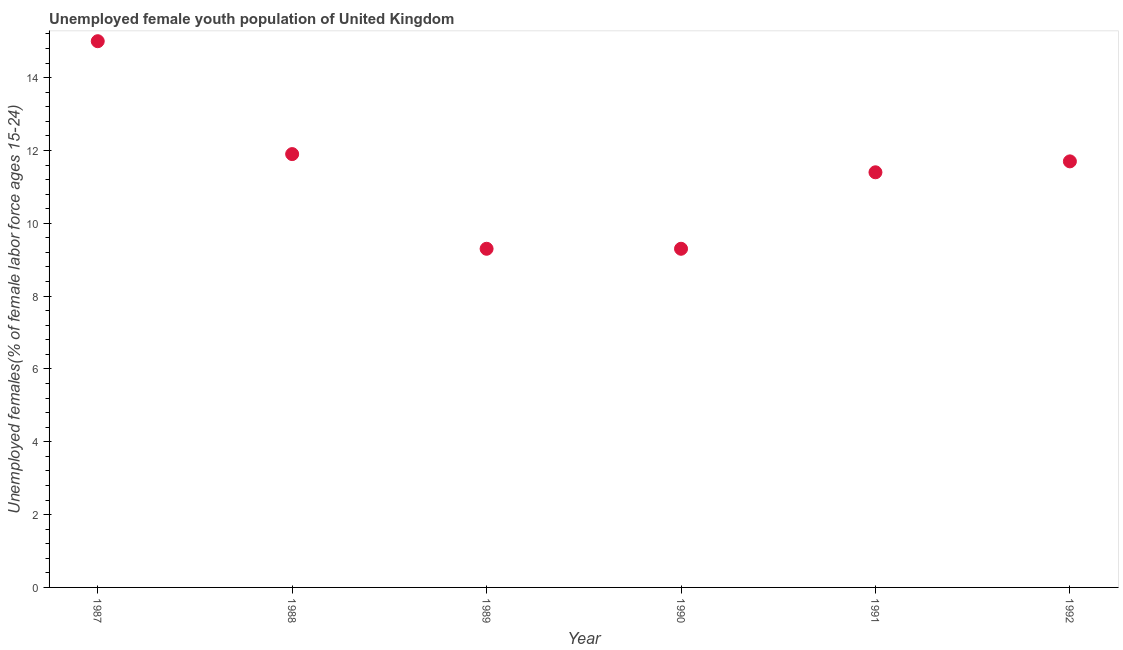What is the unemployed female youth in 1992?
Offer a very short reply. 11.7. Across all years, what is the maximum unemployed female youth?
Provide a short and direct response. 15. Across all years, what is the minimum unemployed female youth?
Provide a short and direct response. 9.3. What is the sum of the unemployed female youth?
Provide a short and direct response. 68.6. What is the difference between the unemployed female youth in 1987 and 1991?
Provide a short and direct response. 3.6. What is the average unemployed female youth per year?
Keep it short and to the point. 11.43. What is the median unemployed female youth?
Offer a very short reply. 11.55. In how many years, is the unemployed female youth greater than 6 %?
Provide a succinct answer. 6. Do a majority of the years between 1990 and 1988 (inclusive) have unemployed female youth greater than 10 %?
Keep it short and to the point. No. What is the ratio of the unemployed female youth in 1988 to that in 1989?
Your response must be concise. 1.28. Is the unemployed female youth in 1990 less than that in 1991?
Keep it short and to the point. Yes. Is the difference between the unemployed female youth in 1987 and 1991 greater than the difference between any two years?
Offer a terse response. No. What is the difference between the highest and the second highest unemployed female youth?
Your answer should be very brief. 3.1. Is the sum of the unemployed female youth in 1990 and 1991 greater than the maximum unemployed female youth across all years?
Ensure brevity in your answer.  Yes. What is the difference between the highest and the lowest unemployed female youth?
Ensure brevity in your answer.  5.7. In how many years, is the unemployed female youth greater than the average unemployed female youth taken over all years?
Your answer should be very brief. 3. Are the values on the major ticks of Y-axis written in scientific E-notation?
Your answer should be very brief. No. Does the graph contain any zero values?
Offer a very short reply. No. Does the graph contain grids?
Offer a very short reply. No. What is the title of the graph?
Offer a terse response. Unemployed female youth population of United Kingdom. What is the label or title of the X-axis?
Keep it short and to the point. Year. What is the label or title of the Y-axis?
Your answer should be compact. Unemployed females(% of female labor force ages 15-24). What is the Unemployed females(% of female labor force ages 15-24) in 1988?
Give a very brief answer. 11.9. What is the Unemployed females(% of female labor force ages 15-24) in 1989?
Provide a short and direct response. 9.3. What is the Unemployed females(% of female labor force ages 15-24) in 1990?
Make the answer very short. 9.3. What is the Unemployed females(% of female labor force ages 15-24) in 1991?
Keep it short and to the point. 11.4. What is the Unemployed females(% of female labor force ages 15-24) in 1992?
Your answer should be compact. 11.7. What is the difference between the Unemployed females(% of female labor force ages 15-24) in 1987 and 1988?
Provide a short and direct response. 3.1. What is the difference between the Unemployed females(% of female labor force ages 15-24) in 1987 and 1991?
Your response must be concise. 3.6. What is the difference between the Unemployed females(% of female labor force ages 15-24) in 1987 and 1992?
Your answer should be compact. 3.3. What is the difference between the Unemployed females(% of female labor force ages 15-24) in 1988 and 1989?
Offer a terse response. 2.6. What is the difference between the Unemployed females(% of female labor force ages 15-24) in 1988 and 1990?
Give a very brief answer. 2.6. What is the difference between the Unemployed females(% of female labor force ages 15-24) in 1988 and 1991?
Offer a very short reply. 0.5. What is the difference between the Unemployed females(% of female labor force ages 15-24) in 1988 and 1992?
Give a very brief answer. 0.2. What is the difference between the Unemployed females(% of female labor force ages 15-24) in 1989 and 1992?
Your response must be concise. -2.4. What is the difference between the Unemployed females(% of female labor force ages 15-24) in 1990 and 1991?
Give a very brief answer. -2.1. What is the difference between the Unemployed females(% of female labor force ages 15-24) in 1990 and 1992?
Provide a succinct answer. -2.4. What is the difference between the Unemployed females(% of female labor force ages 15-24) in 1991 and 1992?
Keep it short and to the point. -0.3. What is the ratio of the Unemployed females(% of female labor force ages 15-24) in 1987 to that in 1988?
Offer a terse response. 1.26. What is the ratio of the Unemployed females(% of female labor force ages 15-24) in 1987 to that in 1989?
Provide a short and direct response. 1.61. What is the ratio of the Unemployed females(% of female labor force ages 15-24) in 1987 to that in 1990?
Your response must be concise. 1.61. What is the ratio of the Unemployed females(% of female labor force ages 15-24) in 1987 to that in 1991?
Your answer should be very brief. 1.32. What is the ratio of the Unemployed females(% of female labor force ages 15-24) in 1987 to that in 1992?
Provide a short and direct response. 1.28. What is the ratio of the Unemployed females(% of female labor force ages 15-24) in 1988 to that in 1989?
Make the answer very short. 1.28. What is the ratio of the Unemployed females(% of female labor force ages 15-24) in 1988 to that in 1990?
Your answer should be very brief. 1.28. What is the ratio of the Unemployed females(% of female labor force ages 15-24) in 1988 to that in 1991?
Your answer should be very brief. 1.04. What is the ratio of the Unemployed females(% of female labor force ages 15-24) in 1989 to that in 1991?
Provide a succinct answer. 0.82. What is the ratio of the Unemployed females(% of female labor force ages 15-24) in 1989 to that in 1992?
Your answer should be compact. 0.8. What is the ratio of the Unemployed females(% of female labor force ages 15-24) in 1990 to that in 1991?
Make the answer very short. 0.82. What is the ratio of the Unemployed females(% of female labor force ages 15-24) in 1990 to that in 1992?
Your response must be concise. 0.8. 